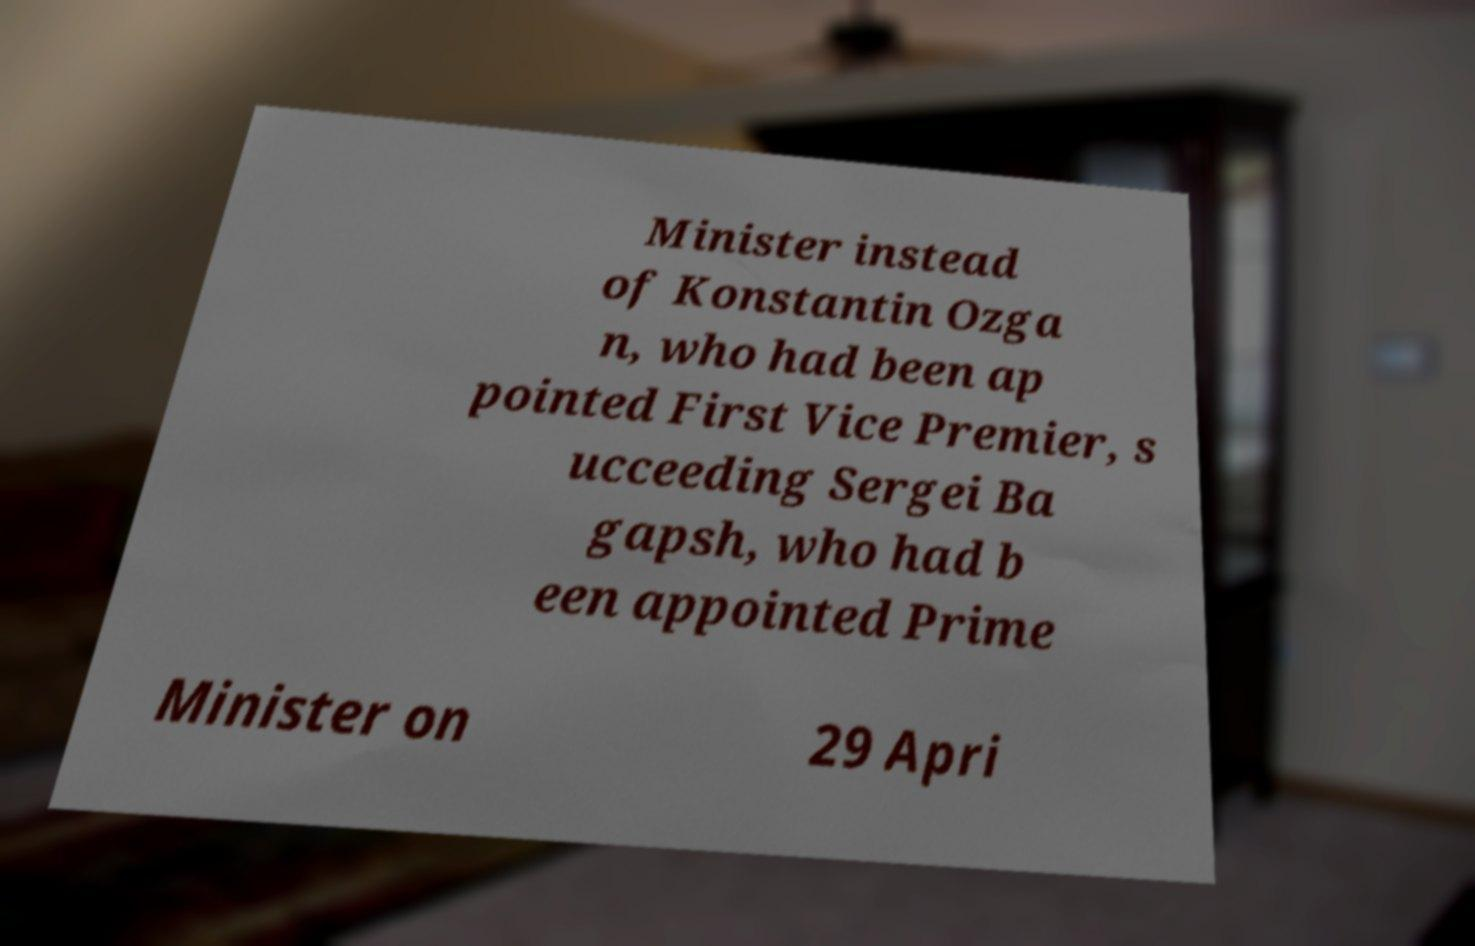There's text embedded in this image that I need extracted. Can you transcribe it verbatim? Minister instead of Konstantin Ozga n, who had been ap pointed First Vice Premier, s ucceeding Sergei Ba gapsh, who had b een appointed Prime Minister on 29 Apri 